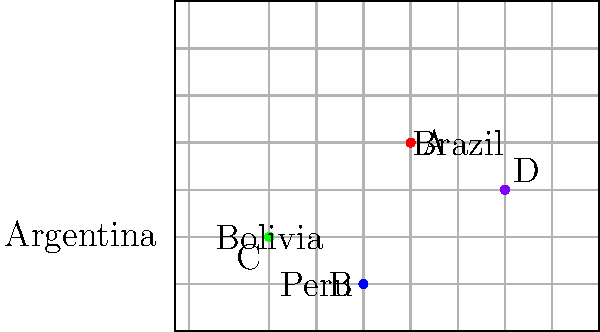The map shows the geographical distribution of four indigenous artists (A, B, C, and D) represented in the art collection. Which artist is located closest to the Equator? To determine which artist is closest to the Equator, we need to follow these steps:

1. Recall that the Equator is located at 0° latitude.
2. Identify the approximate latitudes of each artist:
   Artist A: 0°
   Artist B: -5°
   Artist C: -15°
   Artist D: 10°
3. Calculate the absolute difference between each artist's latitude and the Equator (0°):
   Artist A: |0 - 0| = 0°
   Artist B: |-5 - 0| = 5°
   Artist C: |-15 - 0| = 15°
   Artist D: |10 - 0| = 10°
4. The artist with the smallest difference is closest to the Equator.

Artist A has the smallest difference (0°), meaning they are located directly on the Equator.
Answer: A 